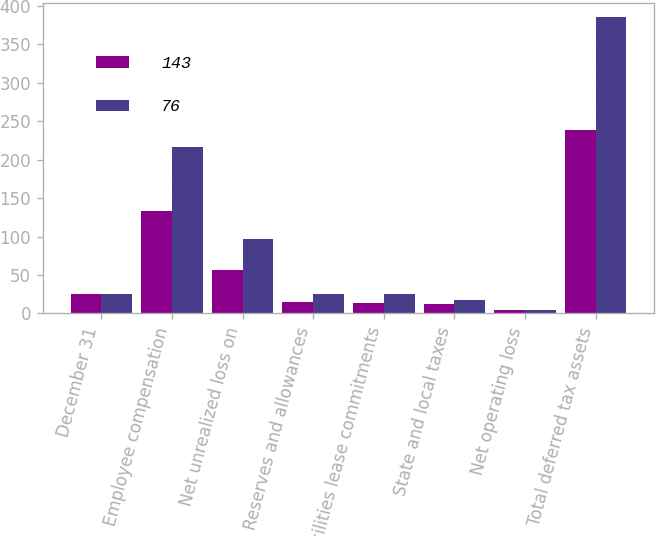<chart> <loc_0><loc_0><loc_500><loc_500><stacked_bar_chart><ecel><fcel>December 31<fcel>Employee compensation<fcel>Net unrealized loss on<fcel>Reserves and allowances<fcel>Facilities lease commitments<fcel>State and local taxes<fcel>Net operating loss<fcel>Total deferred tax assets<nl><fcel>143<fcel>25<fcel>133<fcel>57<fcel>15<fcel>14<fcel>12<fcel>5<fcel>239<nl><fcel>76<fcel>25<fcel>216<fcel>97<fcel>25<fcel>25<fcel>17<fcel>5<fcel>385<nl></chart> 